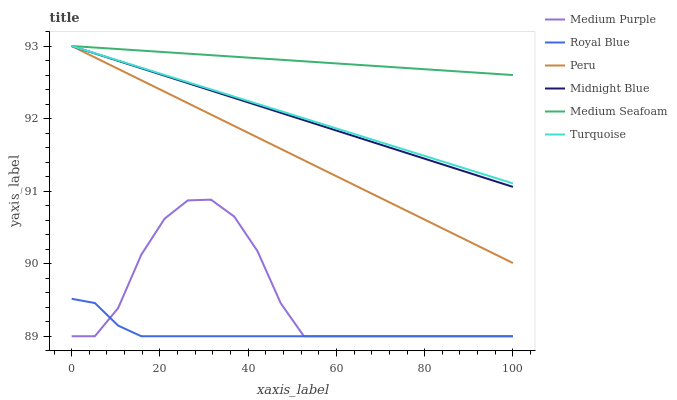Does Royal Blue have the minimum area under the curve?
Answer yes or no. Yes. Does Medium Seafoam have the maximum area under the curve?
Answer yes or no. Yes. Does Midnight Blue have the minimum area under the curve?
Answer yes or no. No. Does Midnight Blue have the maximum area under the curve?
Answer yes or no. No. Is Peru the smoothest?
Answer yes or no. Yes. Is Medium Purple the roughest?
Answer yes or no. Yes. Is Midnight Blue the smoothest?
Answer yes or no. No. Is Midnight Blue the roughest?
Answer yes or no. No. Does Medium Purple have the lowest value?
Answer yes or no. Yes. Does Midnight Blue have the lowest value?
Answer yes or no. No. Does Medium Seafoam have the highest value?
Answer yes or no. Yes. Does Medium Purple have the highest value?
Answer yes or no. No. Is Royal Blue less than Peru?
Answer yes or no. Yes. Is Medium Seafoam greater than Royal Blue?
Answer yes or no. Yes. Does Midnight Blue intersect Peru?
Answer yes or no. Yes. Is Midnight Blue less than Peru?
Answer yes or no. No. Is Midnight Blue greater than Peru?
Answer yes or no. No. Does Royal Blue intersect Peru?
Answer yes or no. No. 